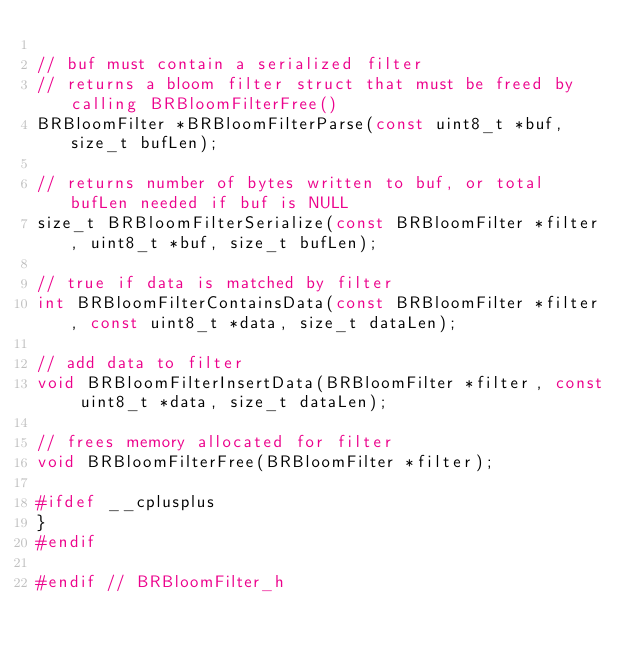<code> <loc_0><loc_0><loc_500><loc_500><_C_>
// buf must contain a serialized filter
// returns a bloom filter struct that must be freed by calling BRBloomFilterFree()
BRBloomFilter *BRBloomFilterParse(const uint8_t *buf, size_t bufLen);

// returns number of bytes written to buf, or total bufLen needed if buf is NULL
size_t BRBloomFilterSerialize(const BRBloomFilter *filter, uint8_t *buf, size_t bufLen);

// true if data is matched by filter
int BRBloomFilterContainsData(const BRBloomFilter *filter, const uint8_t *data, size_t dataLen);

// add data to filter
void BRBloomFilterInsertData(BRBloomFilter *filter, const uint8_t *data, size_t dataLen);

// frees memory allocated for filter
void BRBloomFilterFree(BRBloomFilter *filter);

#ifdef __cplusplus
}
#endif

#endif // BRBloomFilter_h
</code> 